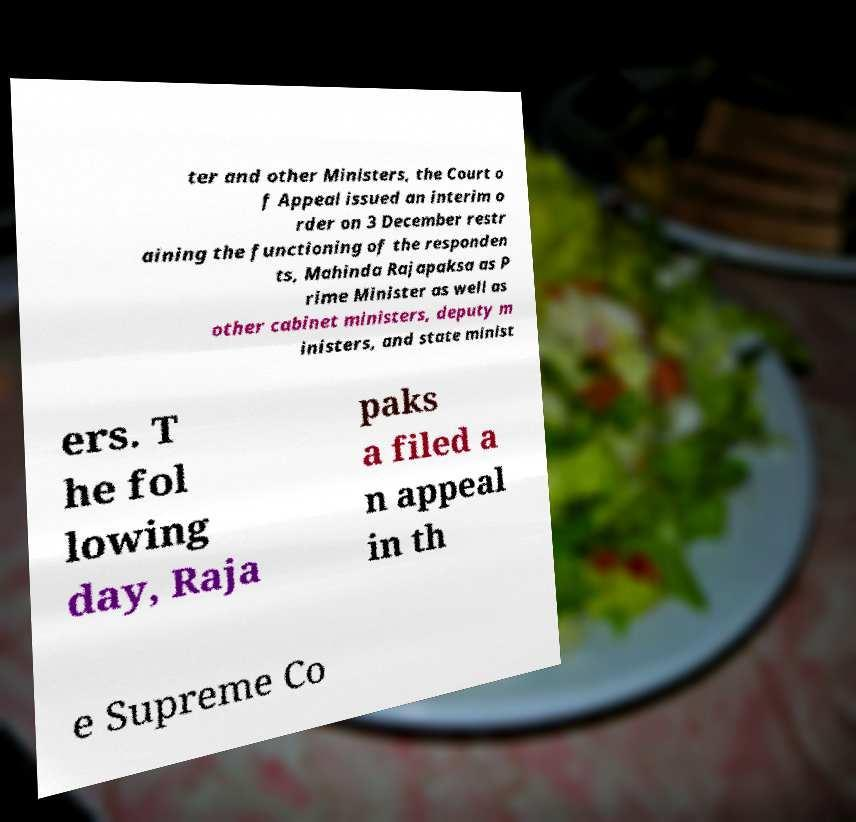There's text embedded in this image that I need extracted. Can you transcribe it verbatim? ter and other Ministers, the Court o f Appeal issued an interim o rder on 3 December restr aining the functioning of the responden ts, Mahinda Rajapaksa as P rime Minister as well as other cabinet ministers, deputy m inisters, and state minist ers. T he fol lowing day, Raja paks a filed a n appeal in th e Supreme Co 